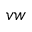Convert formula to latex. <formula><loc_0><loc_0><loc_500><loc_500>v w</formula> 